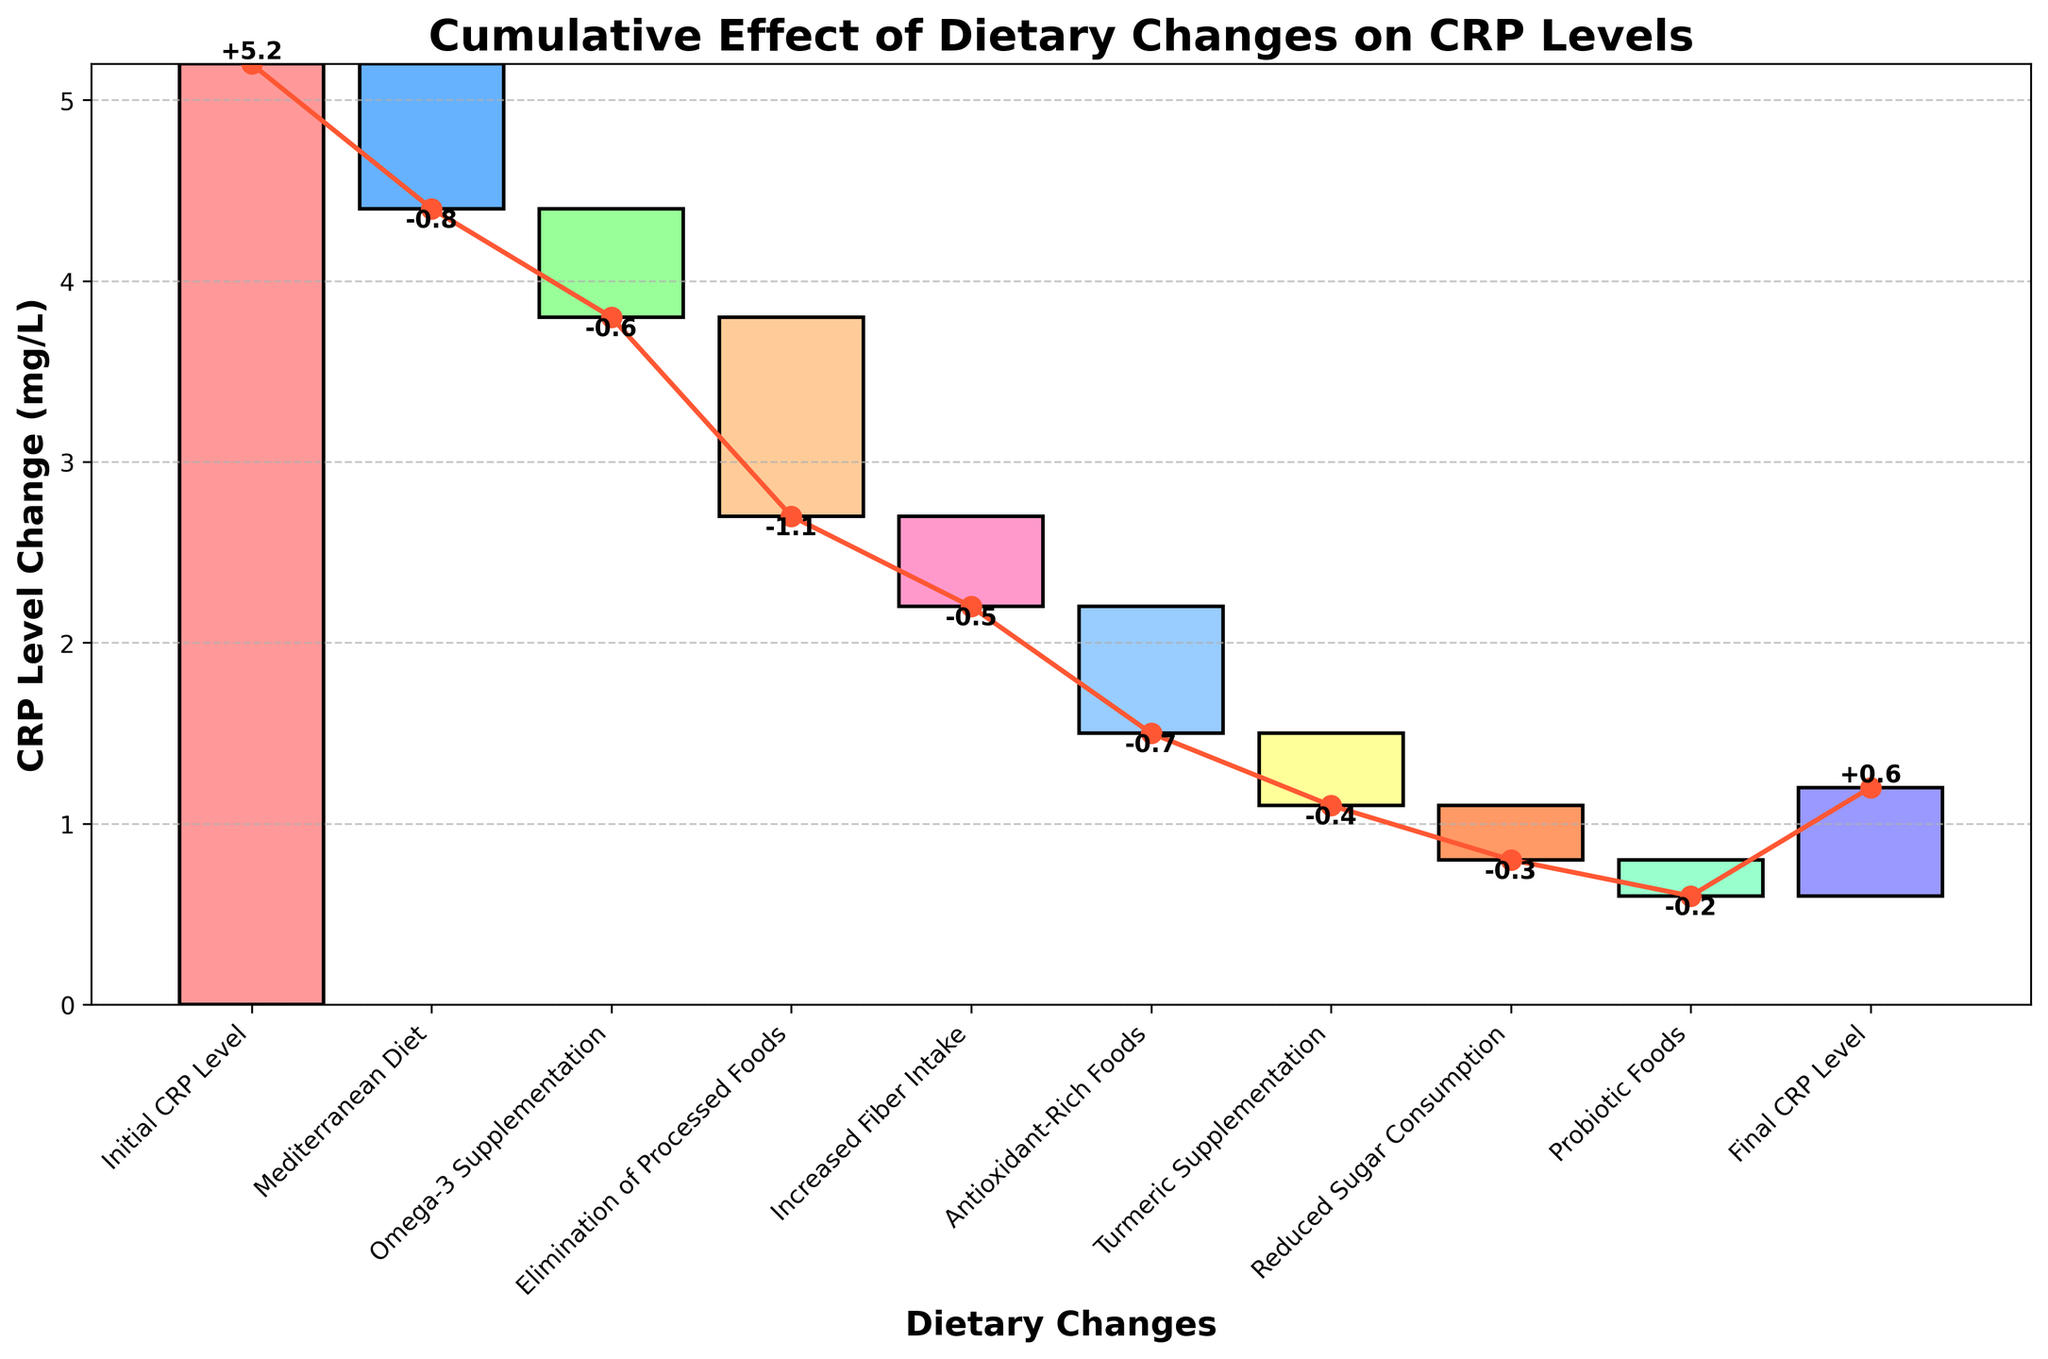What's the title of the figure? The title is displayed prominently at the top of the figure, and it reads "Cumulative Effect of Dietary Changes on CRP Levels". This title gives an overview of what the chart is about.
Answer: Cumulative Effect of Dietary Changes on CRP Levels What does the x-axis represent? The x-axis is labeled "Dietary Changes", and it consists of different dietary interventions and the overall CRP levels at the start and end.
Answer: Dietary Changes How many dietary changes are listed in the figure? By counting the individual dietary changes listed on the x-axis, from "Mediterranean Diet" to "Probiotic Foods", we find there are 8 such categories.
Answer: 8 What was the initial CRP level? The "Initial CRP Level" is directly taken from the first bar in the chart which is labeled with a value. According to the figure, this value is 5.2 mg/L.
Answer: 5.2 mg/L What is the final CRP level after all dietary changes? The "Final CRP Level" is shown as the last bar in the figure and labeled with its value. The chart shows that this final value is 0.6 mg/L.
Answer: 0.6 mg/L Which dietary change had the largest reduction in CRP levels? By visually assessing the length of the bars indicating reductions in CRP levels, the "Elimination of Processed Foods" bar is the longest, indicating the largest reduction. The value is -1.1 mg/L.
Answer: Elimination of Processed Foods What is the cumulative effect of the first three dietary changes? To find the cumulative effect, sum the values of the first three dietary changes: -0.8 (Mediterranean Diet) + -0.6 (Omega-3 Supplementation) + -1.1 (Elimination of Processed Foods) = -2.5.
Answer: -2.5 Which dietary change had the smallest effect on CRP levels? By looking at the values associated with each dietary change, "Probiotic Foods" has the smallest change in CRP levels with a value of -0.2 mg/L.
Answer: Probiotic Foods How does the effect of Turmeric Supplementation compare to Increased Fiber Intake? "Turmeric Supplementation" has a value of -0.4 mg/L and "Increased Fiber Intake" has a value of -0.5 mg/L. By comparing the two values, we see that Increased Fiber Intake has a slightly larger negative effect on CRP levels.
Answer: Increased Fiber Intake has a larger reduction What is the net change in CRP levels after all dietary changes? To find the net change, subtract the final CRP level from the initial CRP level: 5.2 (Initial CRP Level) - 0.6 (Final CRP Level) = 4.6 mg/L.
Answer: 4.6 mg/L 